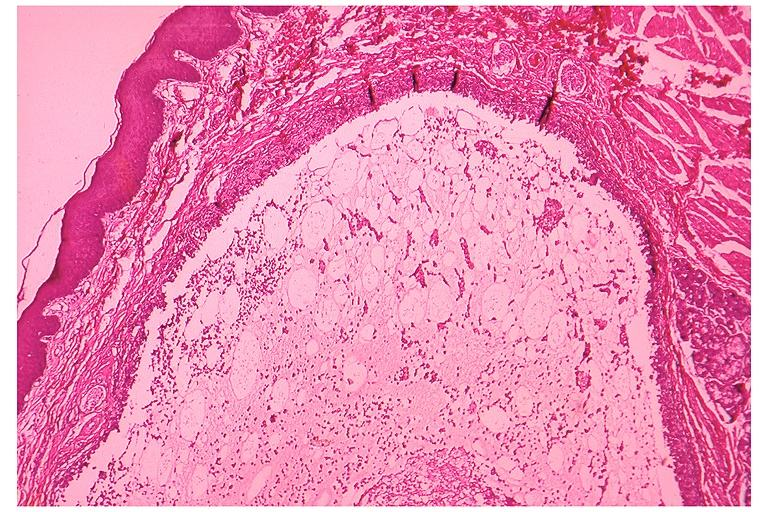what is present?
Answer the question using a single word or phrase. Oral 